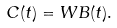<formula> <loc_0><loc_0><loc_500><loc_500>C ( t ) = W B ( t ) .</formula> 